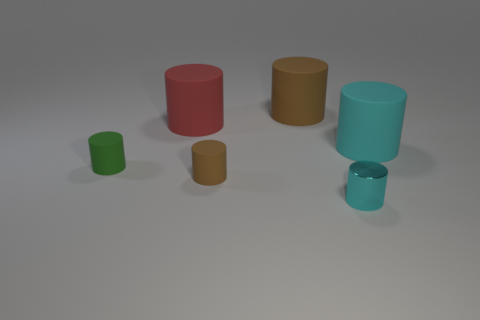Subtract all brown matte cylinders. How many cylinders are left? 4 Subtract all green cylinders. How many cylinders are left? 5 Subtract all green cylinders. Subtract all yellow cubes. How many cylinders are left? 5 Add 2 brown cylinders. How many objects exist? 8 Add 6 large brown rubber objects. How many large brown rubber objects are left? 7 Add 3 small green rubber balls. How many small green rubber balls exist? 3 Subtract 0 red balls. How many objects are left? 6 Subtract all spheres. Subtract all small green things. How many objects are left? 5 